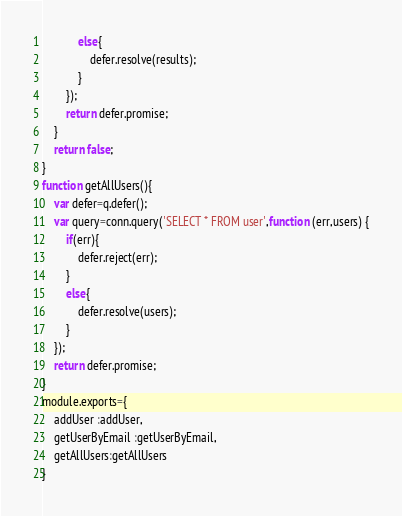Convert code to text. <code><loc_0><loc_0><loc_500><loc_500><_JavaScript_>            else{
                defer.resolve(results);
            }
        });
        return defer.promise;
    }
    return false;
}
function getAllUsers(){
    var defer=q.defer();
    var query=conn.query('SELECT * FROM user',function (err,users) {
        if(err){
            defer.reject(err);
        }
        else{
            defer.resolve(users);
        }
    });
    return defer.promise;
}
module.exports={
    addUser :addUser,
    getUserByEmail :getUserByEmail,
    getAllUsers:getAllUsers
}</code> 